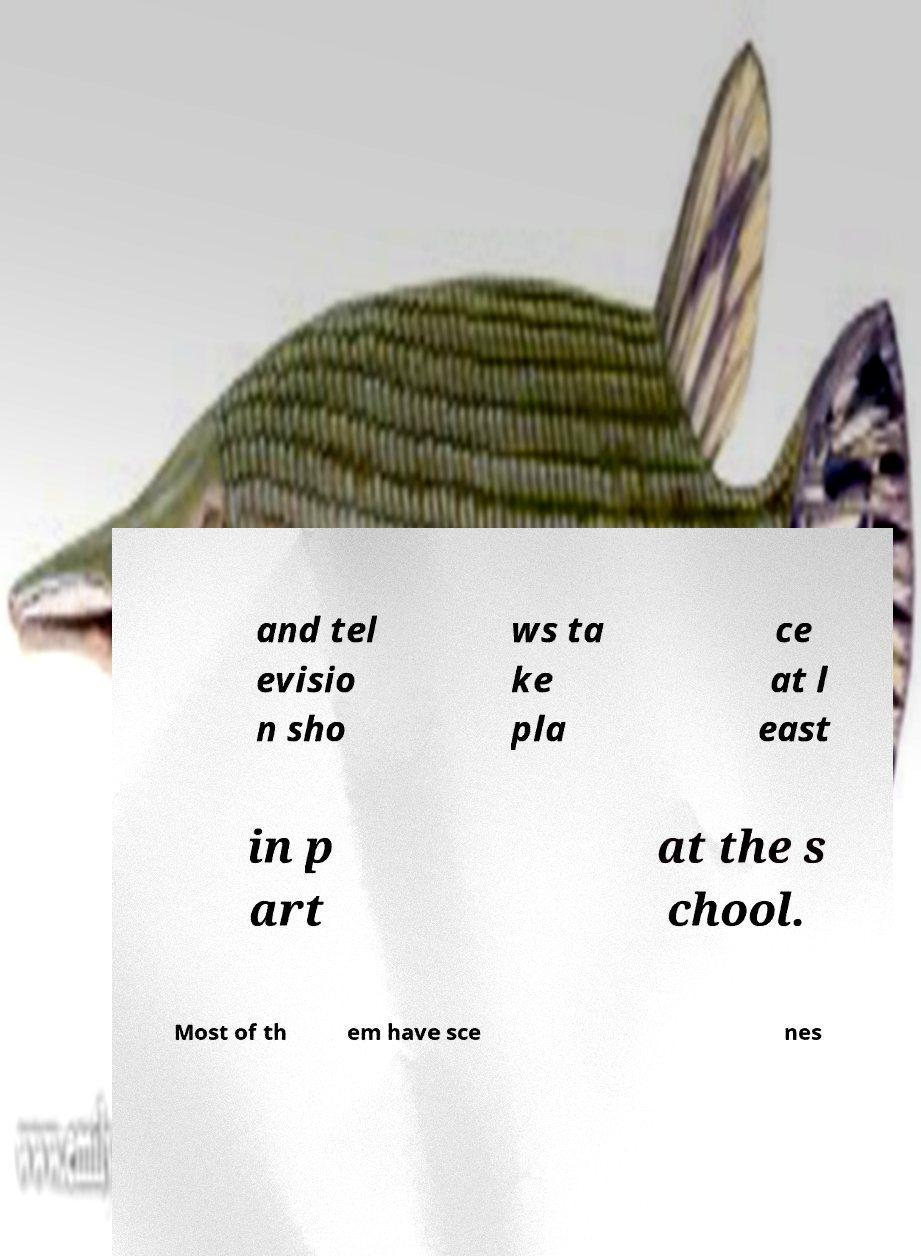What messages or text are displayed in this image? I need them in a readable, typed format. and tel evisio n sho ws ta ke pla ce at l east in p art at the s chool. Most of th em have sce nes 